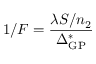<formula> <loc_0><loc_0><loc_500><loc_500>1 / F = \frac { \lambda S / n _ { 2 } } { \Delta _ { G P } ^ { * } }</formula> 